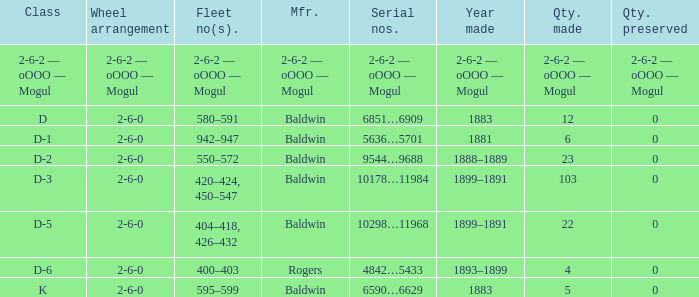What is the quantity made when the class is d-2? 23.0. 